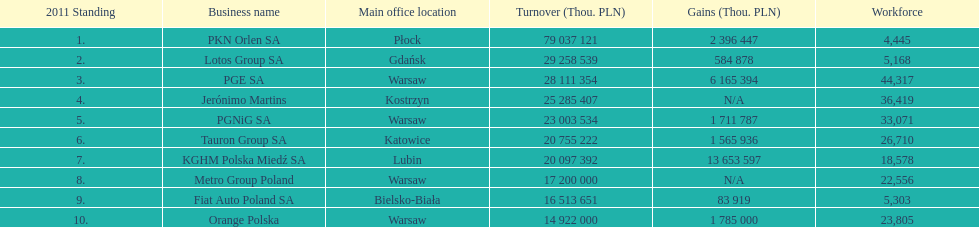What are the names of the major companies of poland? PKN Orlen SA, Lotos Group SA, PGE SA, Jerónimo Martins, PGNiG SA, Tauron Group SA, KGHM Polska Miedź SA, Metro Group Poland, Fiat Auto Poland SA, Orange Polska. What are the revenues of those companies in thou. pln? PKN Orlen SA, 79 037 121, Lotos Group SA, 29 258 539, PGE SA, 28 111 354, Jerónimo Martins, 25 285 407, PGNiG SA, 23 003 534, Tauron Group SA, 20 755 222, KGHM Polska Miedź SA, 20 097 392, Metro Group Poland, 17 200 000, Fiat Auto Poland SA, 16 513 651, Orange Polska, 14 922 000. Which of these revenues is greater than 75 000 000 thou. pln? 79 037 121. Which company has a revenue equal to 79 037 121 thou pln? PKN Orlen SA. 